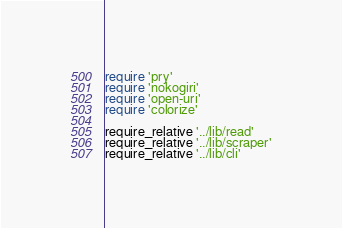Convert code to text. <code><loc_0><loc_0><loc_500><loc_500><_Ruby_>require 'pry'
require 'nokogiri'
require 'open-uri'
require 'colorize'

require_relative '../lib/read'
require_relative '../lib/scraper'
require_relative '../lib/cli'</code> 